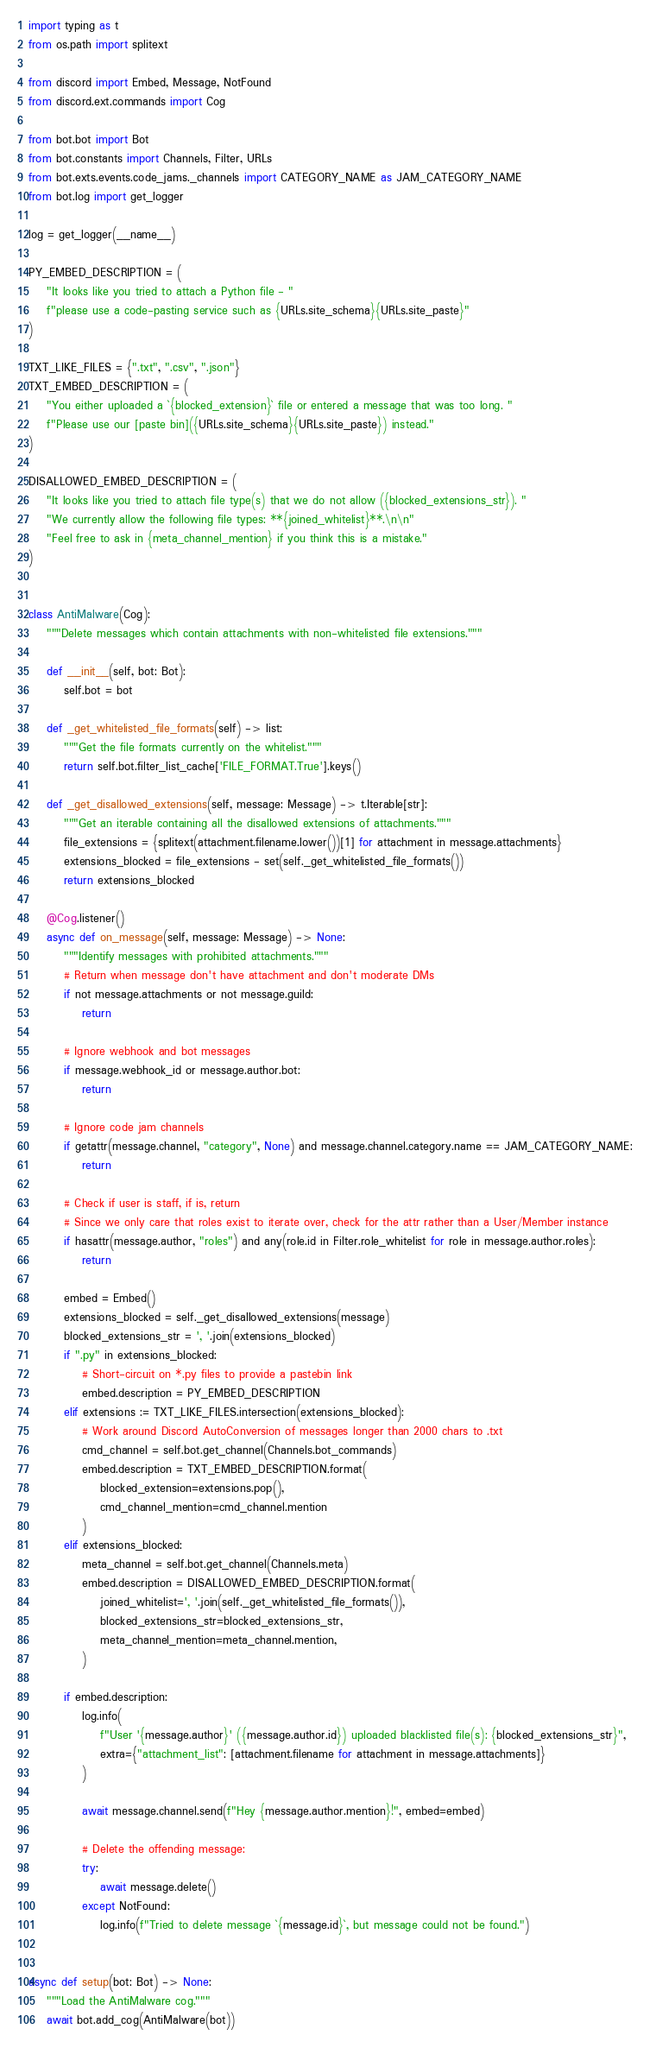Convert code to text. <code><loc_0><loc_0><loc_500><loc_500><_Python_>import typing as t
from os.path import splitext

from discord import Embed, Message, NotFound
from discord.ext.commands import Cog

from bot.bot import Bot
from bot.constants import Channels, Filter, URLs
from bot.exts.events.code_jams._channels import CATEGORY_NAME as JAM_CATEGORY_NAME
from bot.log import get_logger

log = get_logger(__name__)

PY_EMBED_DESCRIPTION = (
    "It looks like you tried to attach a Python file - "
    f"please use a code-pasting service such as {URLs.site_schema}{URLs.site_paste}"
)

TXT_LIKE_FILES = {".txt", ".csv", ".json"}
TXT_EMBED_DESCRIPTION = (
    "You either uploaded a `{blocked_extension}` file or entered a message that was too long. "
    f"Please use our [paste bin]({URLs.site_schema}{URLs.site_paste}) instead."
)

DISALLOWED_EMBED_DESCRIPTION = (
    "It looks like you tried to attach file type(s) that we do not allow ({blocked_extensions_str}). "
    "We currently allow the following file types: **{joined_whitelist}**.\n\n"
    "Feel free to ask in {meta_channel_mention} if you think this is a mistake."
)


class AntiMalware(Cog):
    """Delete messages which contain attachments with non-whitelisted file extensions."""

    def __init__(self, bot: Bot):
        self.bot = bot

    def _get_whitelisted_file_formats(self) -> list:
        """Get the file formats currently on the whitelist."""
        return self.bot.filter_list_cache['FILE_FORMAT.True'].keys()

    def _get_disallowed_extensions(self, message: Message) -> t.Iterable[str]:
        """Get an iterable containing all the disallowed extensions of attachments."""
        file_extensions = {splitext(attachment.filename.lower())[1] for attachment in message.attachments}
        extensions_blocked = file_extensions - set(self._get_whitelisted_file_formats())
        return extensions_blocked

    @Cog.listener()
    async def on_message(self, message: Message) -> None:
        """Identify messages with prohibited attachments."""
        # Return when message don't have attachment and don't moderate DMs
        if not message.attachments or not message.guild:
            return

        # Ignore webhook and bot messages
        if message.webhook_id or message.author.bot:
            return

        # Ignore code jam channels
        if getattr(message.channel, "category", None) and message.channel.category.name == JAM_CATEGORY_NAME:
            return

        # Check if user is staff, if is, return
        # Since we only care that roles exist to iterate over, check for the attr rather than a User/Member instance
        if hasattr(message.author, "roles") and any(role.id in Filter.role_whitelist for role in message.author.roles):
            return

        embed = Embed()
        extensions_blocked = self._get_disallowed_extensions(message)
        blocked_extensions_str = ', '.join(extensions_blocked)
        if ".py" in extensions_blocked:
            # Short-circuit on *.py files to provide a pastebin link
            embed.description = PY_EMBED_DESCRIPTION
        elif extensions := TXT_LIKE_FILES.intersection(extensions_blocked):
            # Work around Discord AutoConversion of messages longer than 2000 chars to .txt
            cmd_channel = self.bot.get_channel(Channels.bot_commands)
            embed.description = TXT_EMBED_DESCRIPTION.format(
                blocked_extension=extensions.pop(),
                cmd_channel_mention=cmd_channel.mention
            )
        elif extensions_blocked:
            meta_channel = self.bot.get_channel(Channels.meta)
            embed.description = DISALLOWED_EMBED_DESCRIPTION.format(
                joined_whitelist=', '.join(self._get_whitelisted_file_formats()),
                blocked_extensions_str=blocked_extensions_str,
                meta_channel_mention=meta_channel.mention,
            )

        if embed.description:
            log.info(
                f"User '{message.author}' ({message.author.id}) uploaded blacklisted file(s): {blocked_extensions_str}",
                extra={"attachment_list": [attachment.filename for attachment in message.attachments]}
            )

            await message.channel.send(f"Hey {message.author.mention}!", embed=embed)

            # Delete the offending message:
            try:
                await message.delete()
            except NotFound:
                log.info(f"Tried to delete message `{message.id}`, but message could not be found.")


async def setup(bot: Bot) -> None:
    """Load the AntiMalware cog."""
    await bot.add_cog(AntiMalware(bot))
</code> 